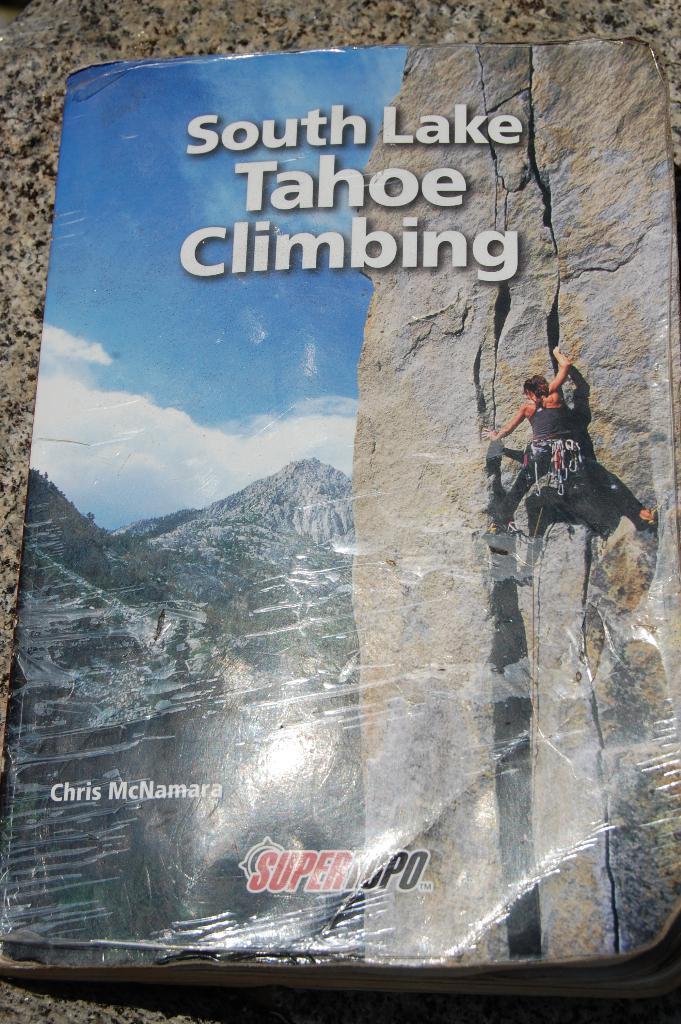Can you describe this image briefly? As we can see in the image there is poster. On poster there are hills, a person wearing black color dress, sky, clouds and there is something written. 